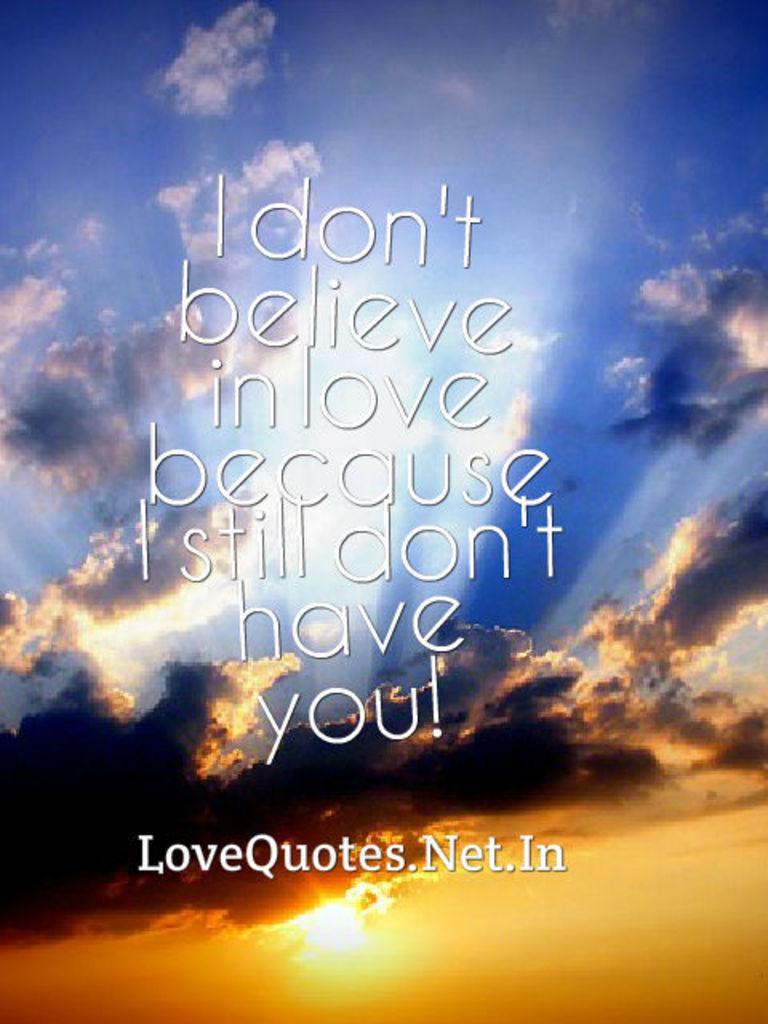Describe this image in one or two sentences. In this image we can see something is written on it. In the background there is sky with clouds. 